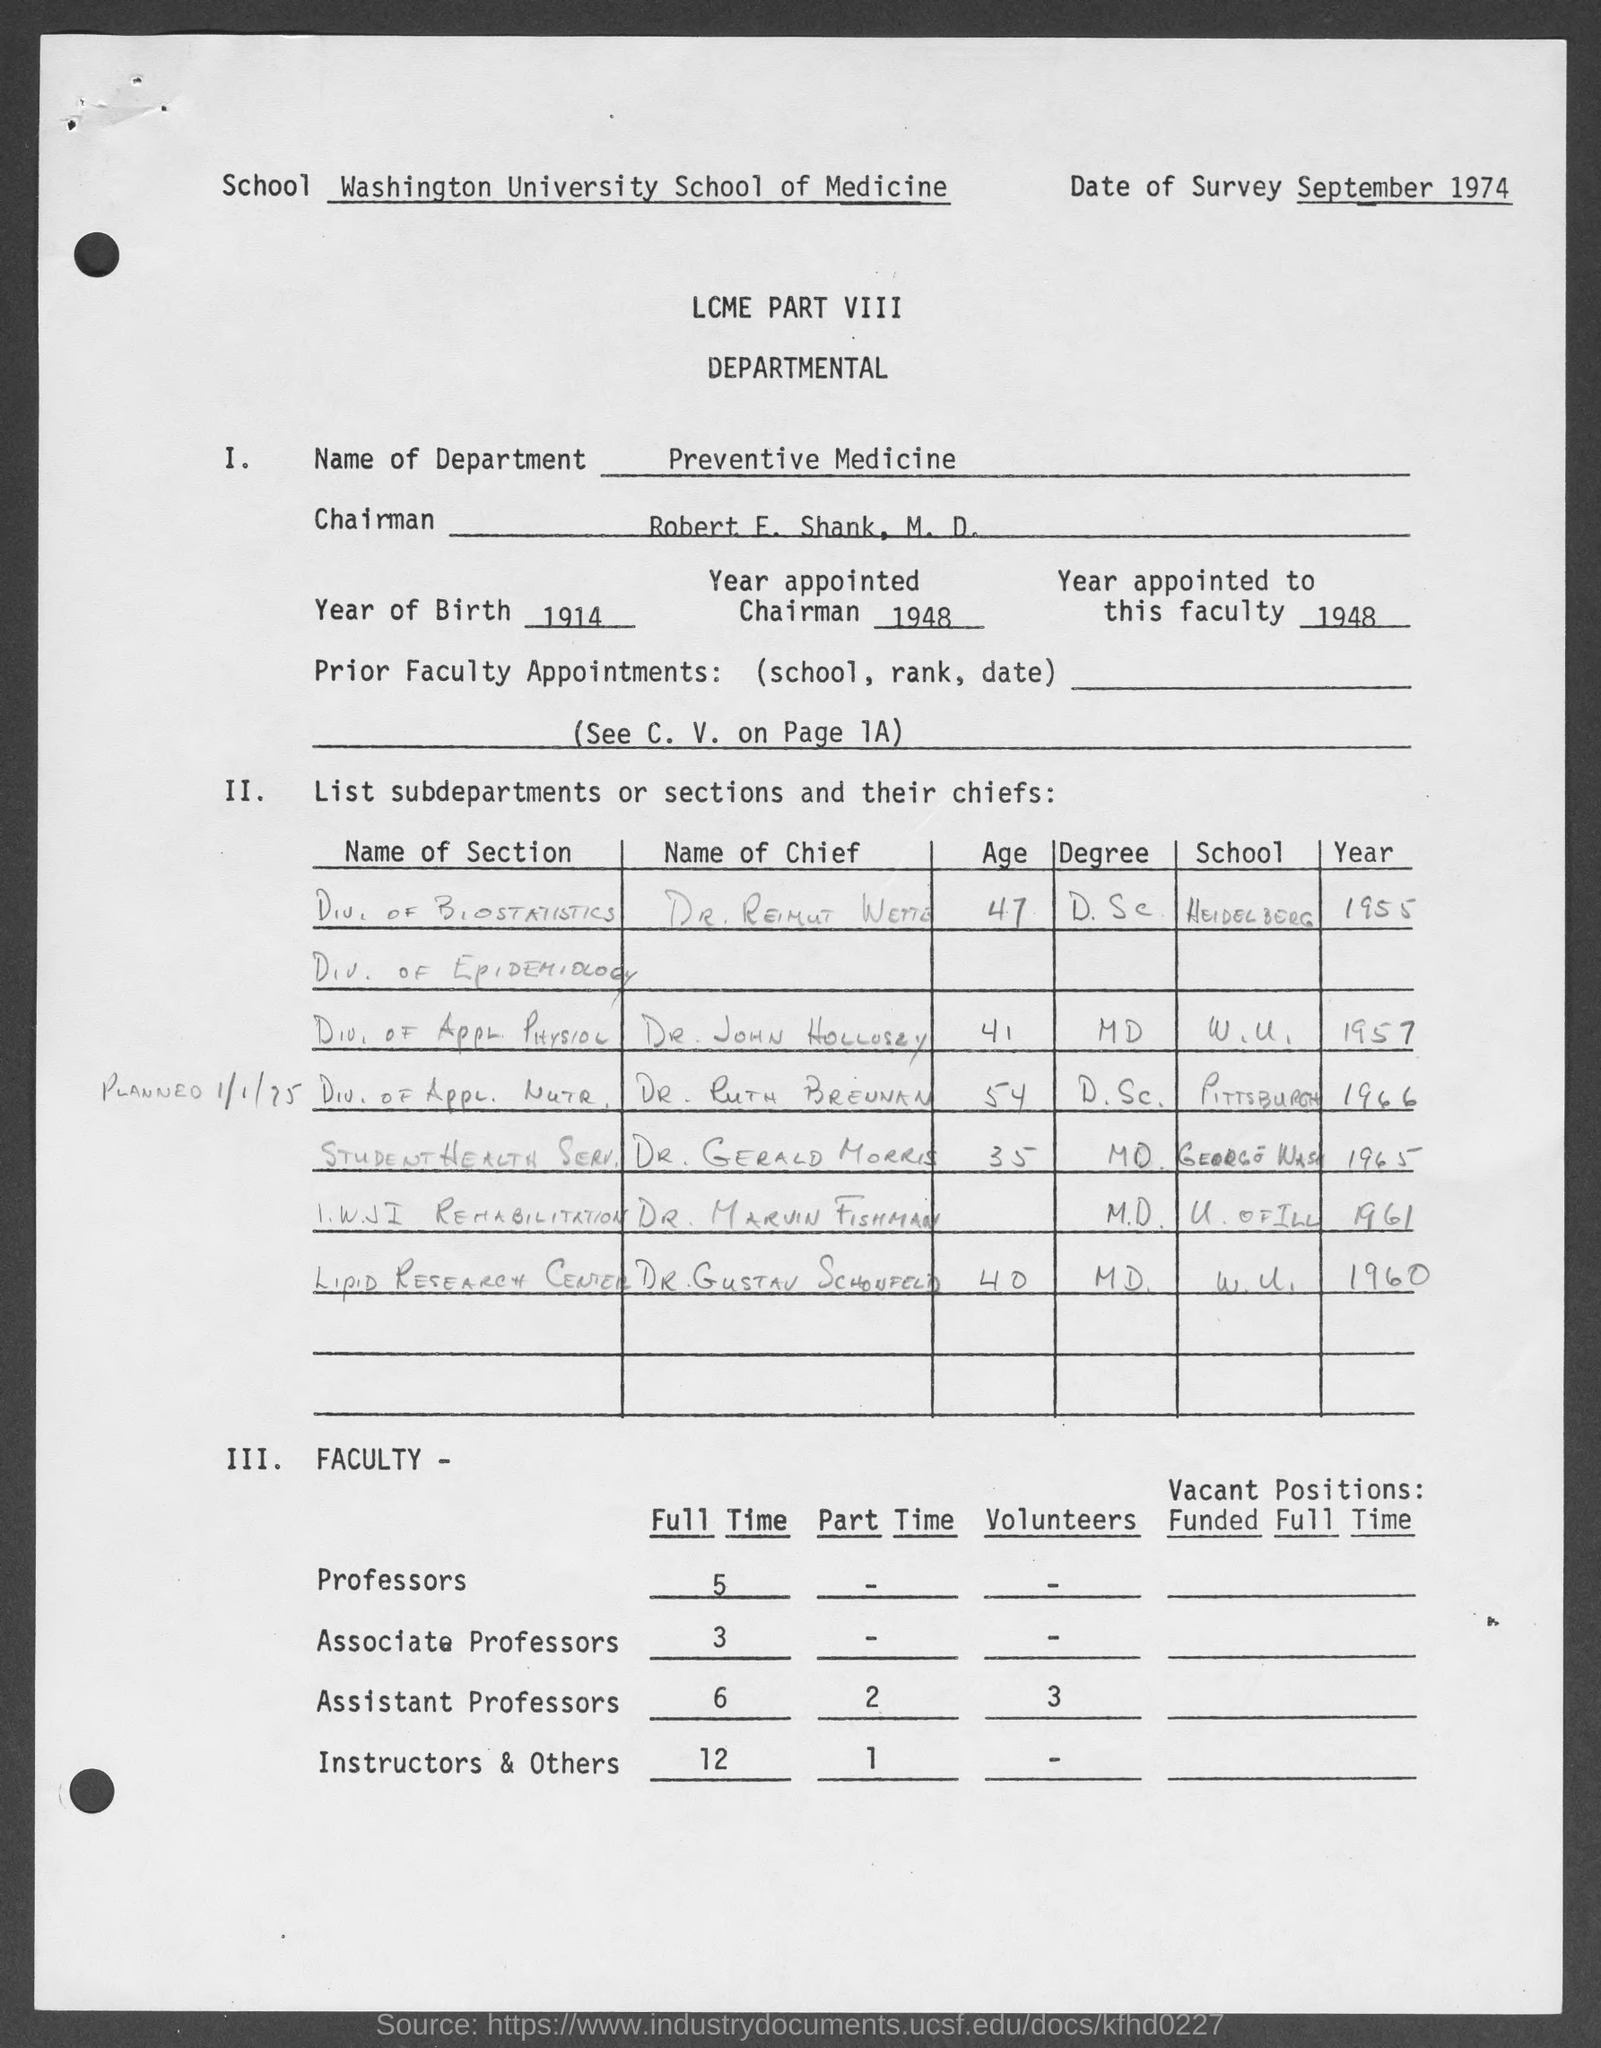What is the name of the school mentioned in the given form ?
Ensure brevity in your answer.  Washington university school of medicine. What is the name of the department mentioned in the given form ?
Ensure brevity in your answer.  Preventive medicine. What is the year of birth mentioned in the given page ?
Your answer should be very brief. 1914. In which year the chairman was appointed as mentioned in the given form ?
Make the answer very short. 1948. What is the year appointed to this faculty as mentioned in the given form ?
Offer a very short reply. 1948. How many no. of full time professors are there as mentioned in the given page ?
Your answer should be very brief. 5. How many no. of full time associate professors are there as mentioned in the given page ?
Keep it short and to the point. 3. How many no. of full time assistant professors are there as mentioned in the given page ?
Give a very brief answer. 6. 